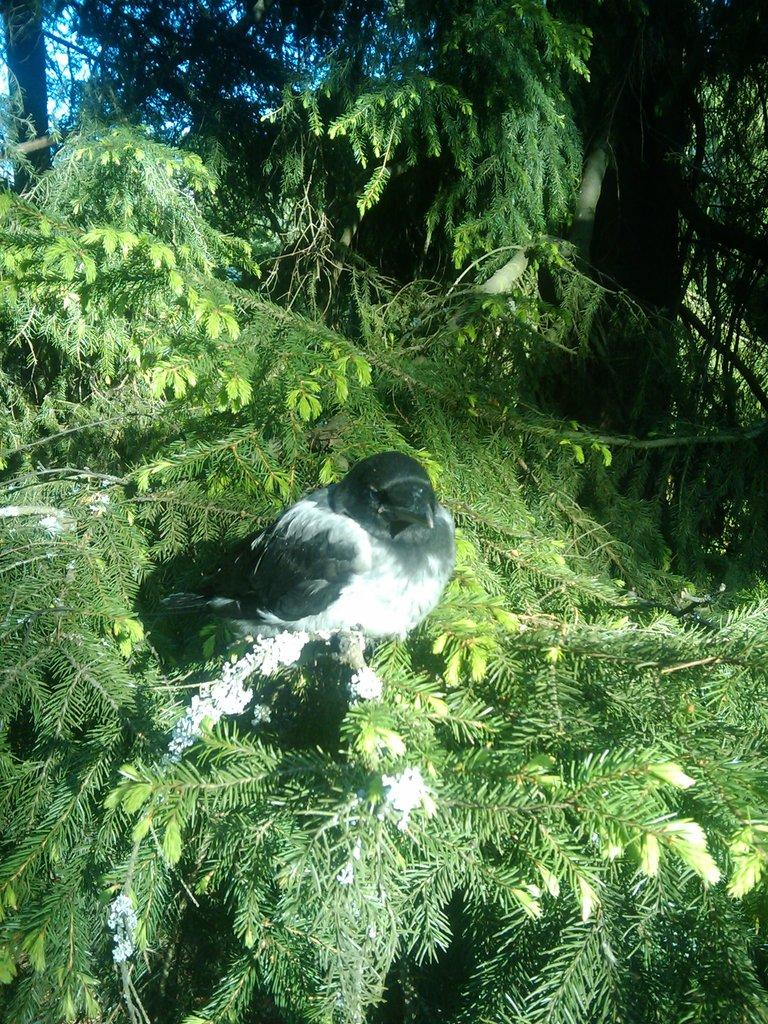What type of animal can be seen in the image? There is a bird in the image. Where is the bird located in the image? The bird is sitting on a tree. What type of mine is visible in the image? There is no mine present in the image; it features a bird sitting on a tree. What kind of pickle can be seen in the image? There is no pickle present in the image. 